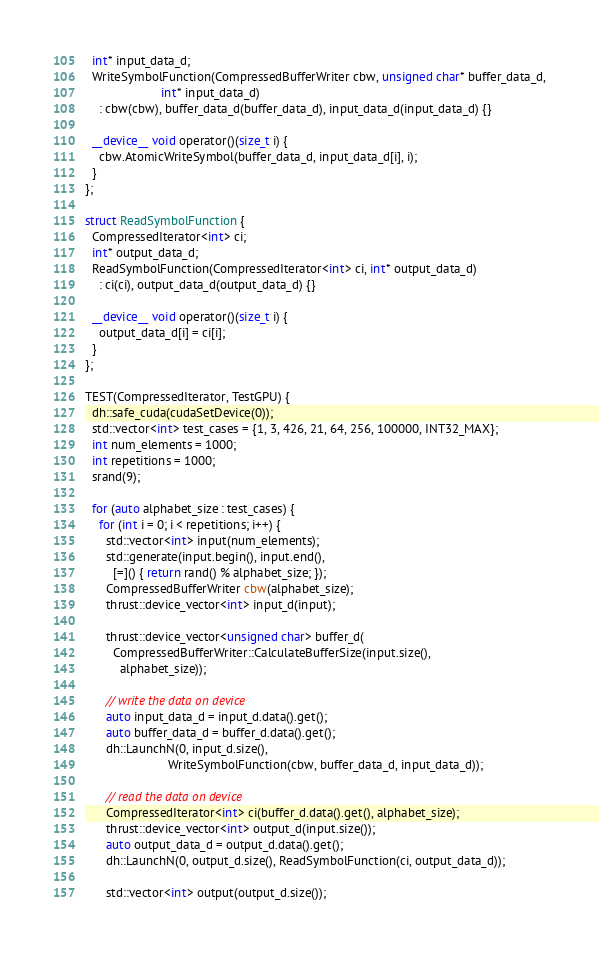Convert code to text. <code><loc_0><loc_0><loc_500><loc_500><_Cuda_>  int* input_data_d;
  WriteSymbolFunction(CompressedBufferWriter cbw, unsigned char* buffer_data_d,
                      int* input_data_d)
    : cbw(cbw), buffer_data_d(buffer_data_d), input_data_d(input_data_d) {}

  __device__ void operator()(size_t i) {
    cbw.AtomicWriteSymbol(buffer_data_d, input_data_d[i], i);
  }
};

struct ReadSymbolFunction {
  CompressedIterator<int> ci;
  int* output_data_d;
  ReadSymbolFunction(CompressedIterator<int> ci, int* output_data_d)
    : ci(ci), output_data_d(output_data_d) {}

  __device__ void operator()(size_t i) {
    output_data_d[i] = ci[i];
  }
};

TEST(CompressedIterator, TestGPU) {
  dh::safe_cuda(cudaSetDevice(0));
  std::vector<int> test_cases = {1, 3, 426, 21, 64, 256, 100000, INT32_MAX};
  int num_elements = 1000;
  int repetitions = 1000;
  srand(9);

  for (auto alphabet_size : test_cases) {
    for (int i = 0; i < repetitions; i++) {
      std::vector<int> input(num_elements);
      std::generate(input.begin(), input.end(),
        [=]() { return rand() % alphabet_size; });
      CompressedBufferWriter cbw(alphabet_size);
      thrust::device_vector<int> input_d(input);

      thrust::device_vector<unsigned char> buffer_d(
        CompressedBufferWriter::CalculateBufferSize(input.size(),
          alphabet_size));

      // write the data on device
      auto input_data_d = input_d.data().get();
      auto buffer_data_d = buffer_d.data().get();
      dh::LaunchN(0, input_d.size(),
                        WriteSymbolFunction(cbw, buffer_data_d, input_data_d));

      // read the data on device
      CompressedIterator<int> ci(buffer_d.data().get(), alphabet_size);
      thrust::device_vector<int> output_d(input.size());
      auto output_data_d = output_d.data().get();
      dh::LaunchN(0, output_d.size(), ReadSymbolFunction(ci, output_data_d));

      std::vector<int> output(output_d.size());</code> 